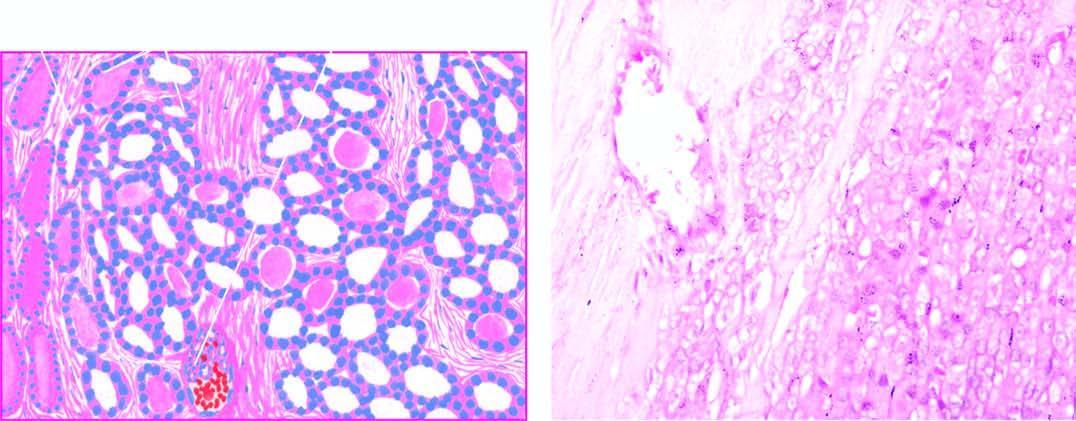s the upper end mild pleomorphism?
Answer the question using a single word or phrase. No 